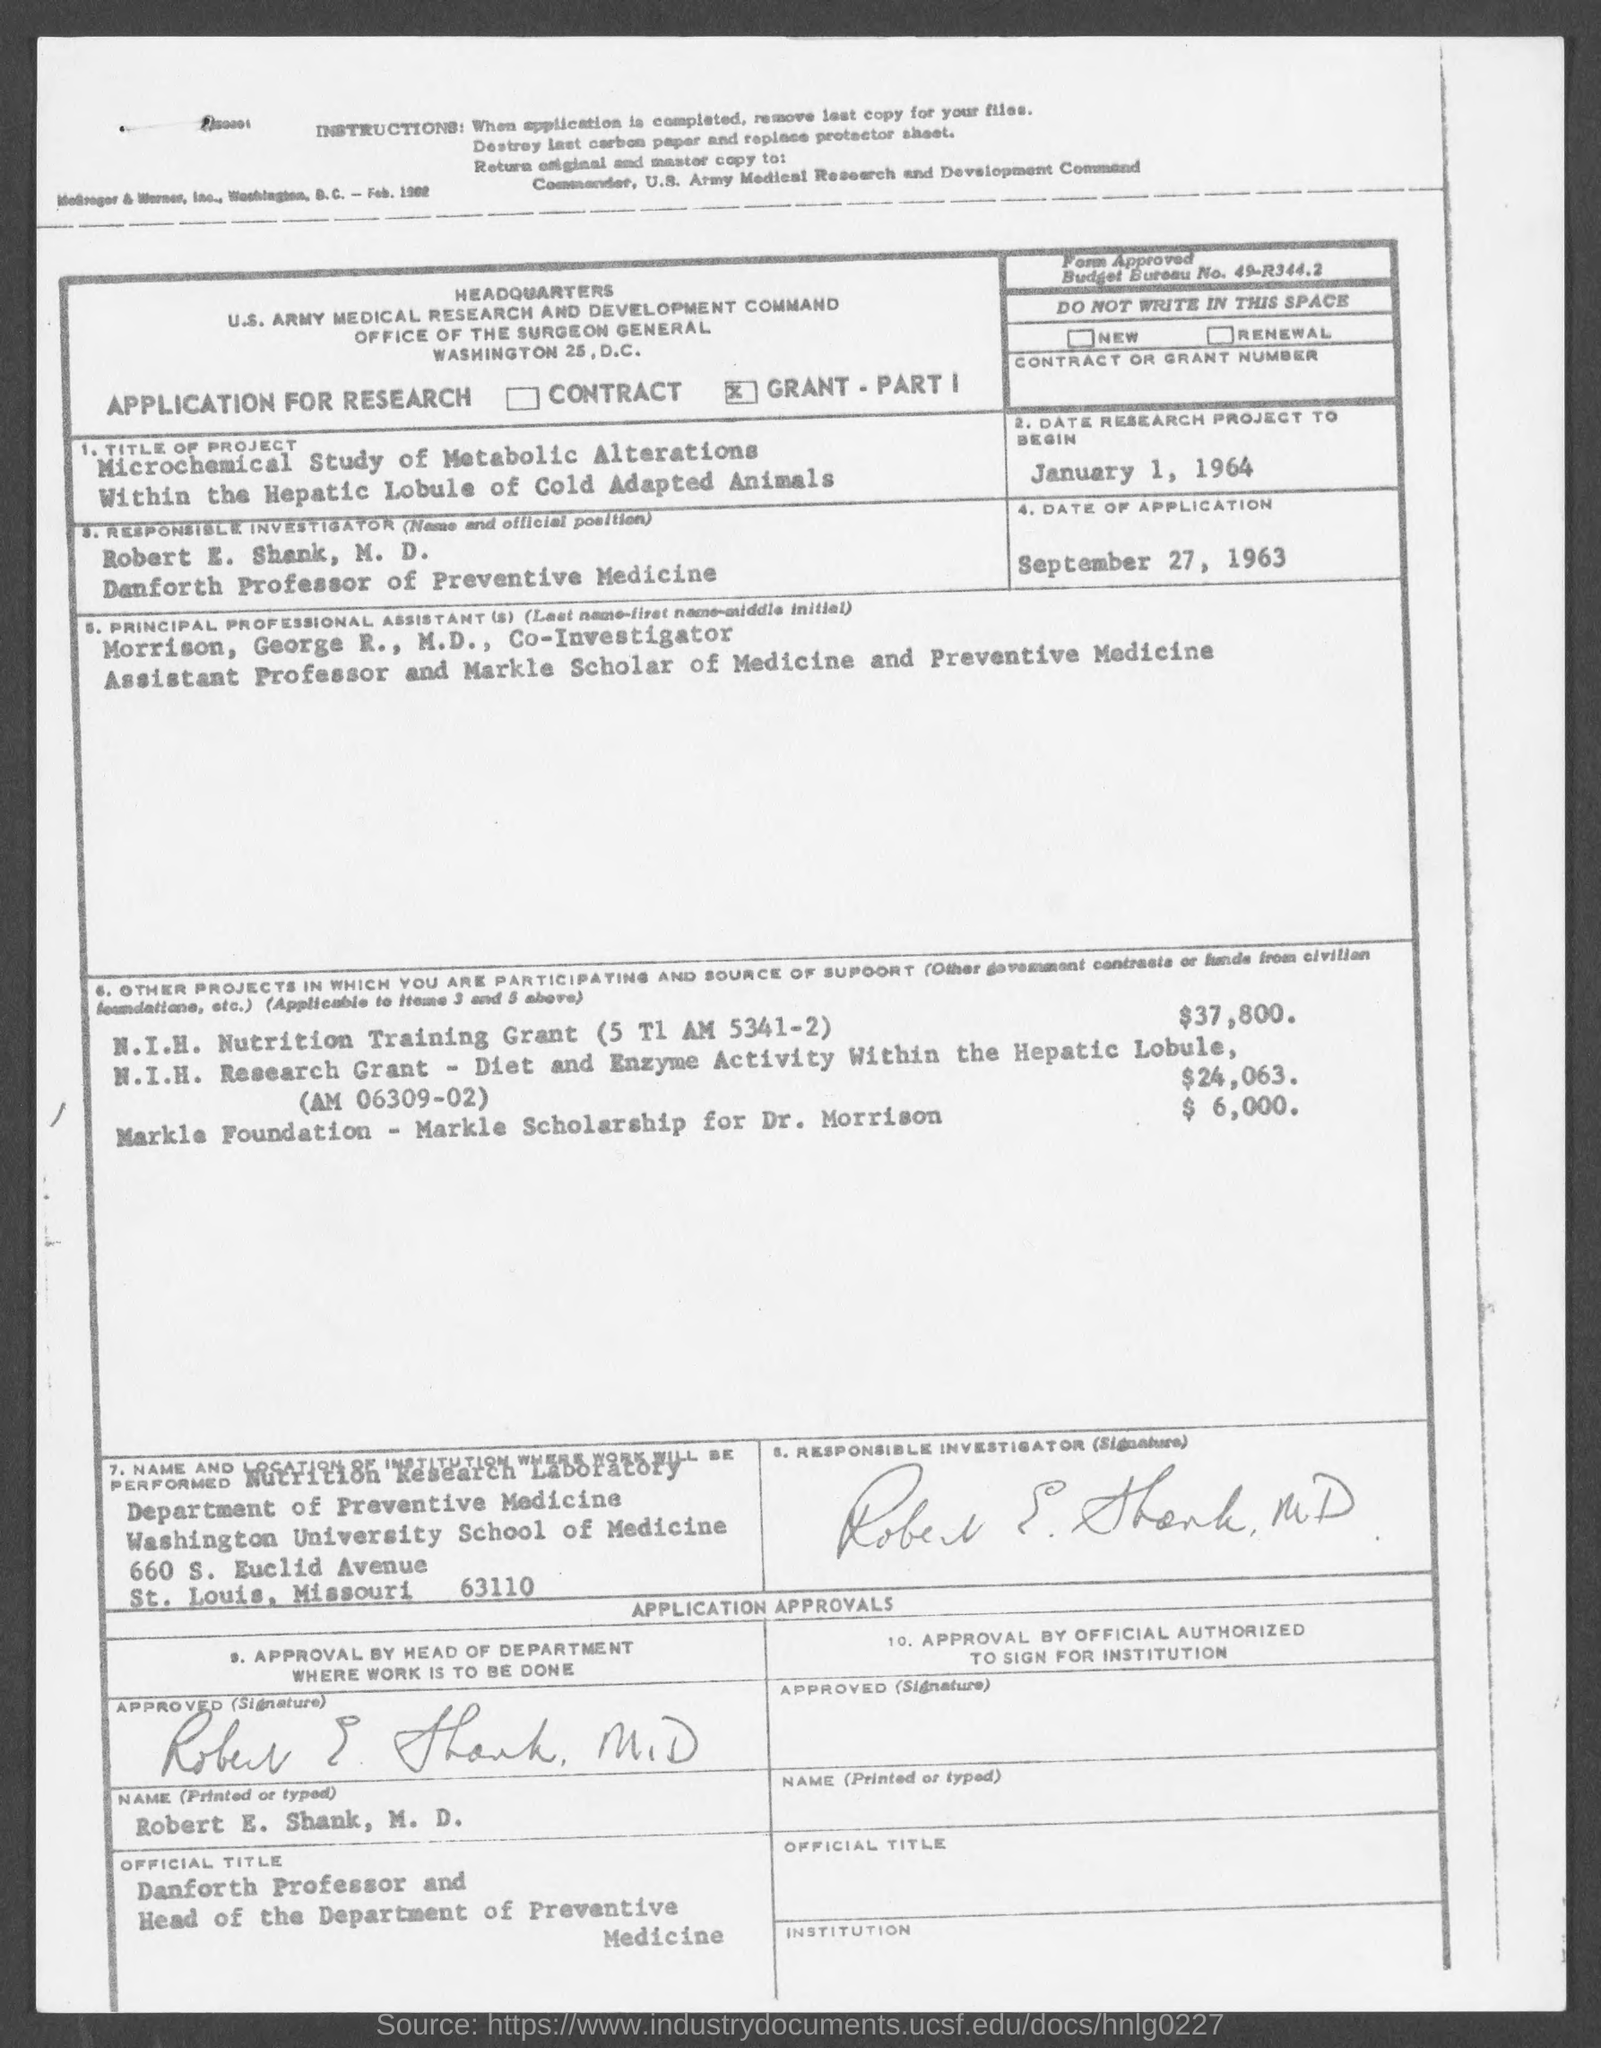Specify some key components in this picture. Robert E. Shank is the responsible investigator mentioned in the given page. The date of the research project as mentioned in the given page is January 1, 1964. The project mentioned on the given page is titled "Microchemical Study of Metabolic Alterations Within the Hepatic Lobule of Cold Adapted Animals. Robert E. Shank holds the designation of Danforth Professor of Preventive Medicine. The principal professional assistants mentioned in the given page are Morrison and George R. 